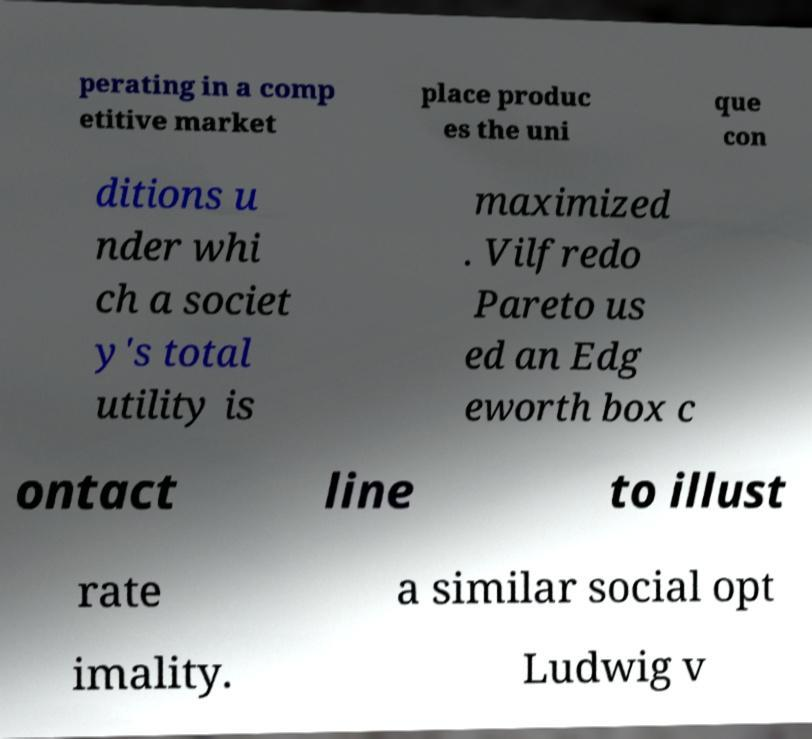What messages or text are displayed in this image? I need them in a readable, typed format. perating in a comp etitive market place produc es the uni que con ditions u nder whi ch a societ y's total utility is maximized . Vilfredo Pareto us ed an Edg eworth box c ontact line to illust rate a similar social opt imality. Ludwig v 